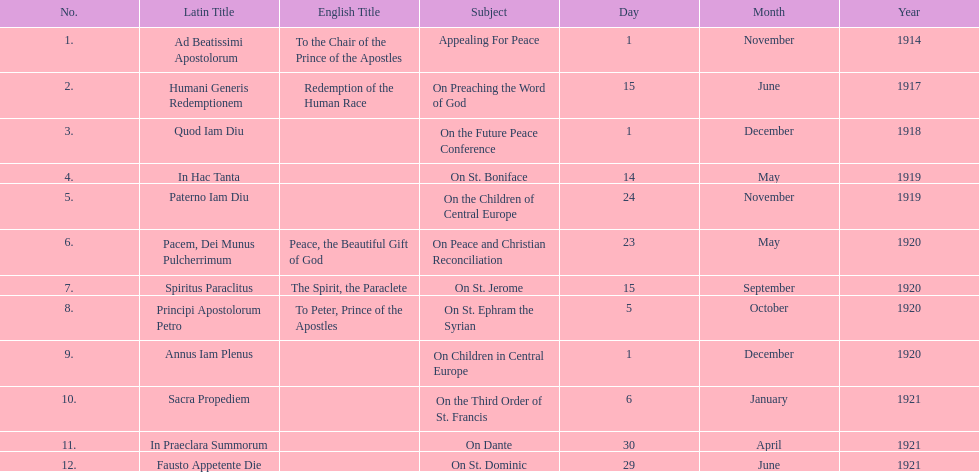What is the next title listed after sacra propediem? In Praeclara Summorum. 